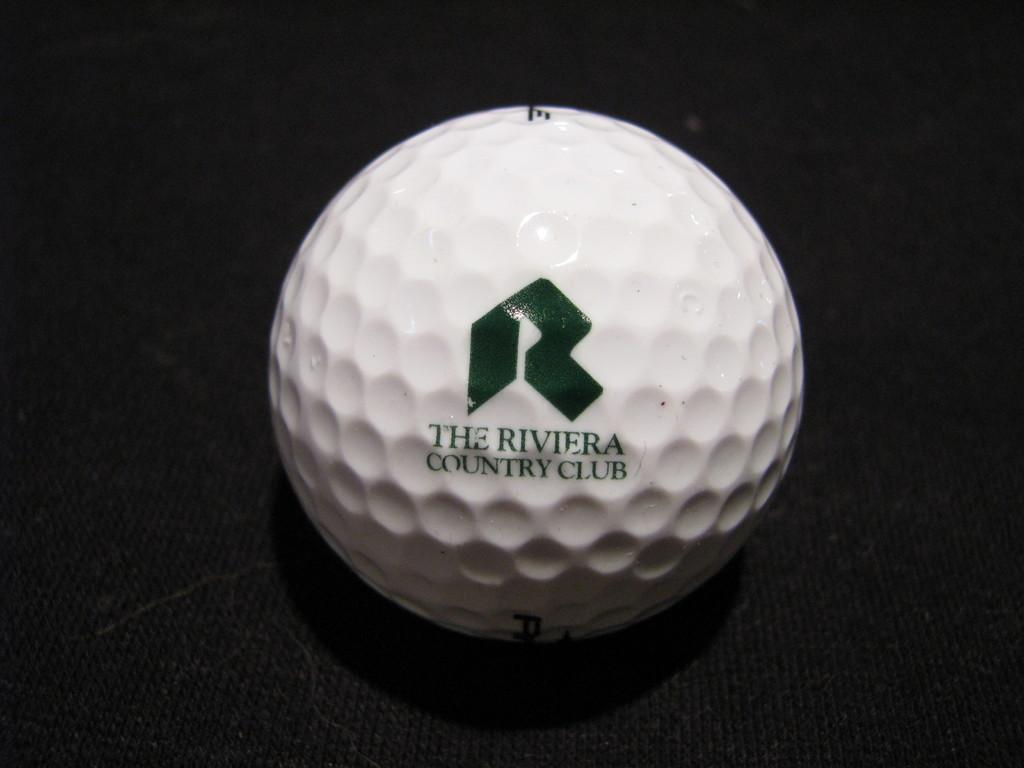What is the primary object in the image? There is a white ball in the image. What is the color of the ball's background? The background of the ball is black. What type of crook is depicted in the image? There is no crook present in the image; it only features a white ball with a black background. 